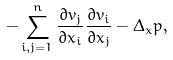<formula> <loc_0><loc_0><loc_500><loc_500>- \sum _ { i , j = 1 } ^ { n } \frac { \partial v _ { j } } { \partial x _ { i } } \frac { \partial v _ { i } } { \partial x _ { j } } - \Delta _ { x } p ,</formula> 